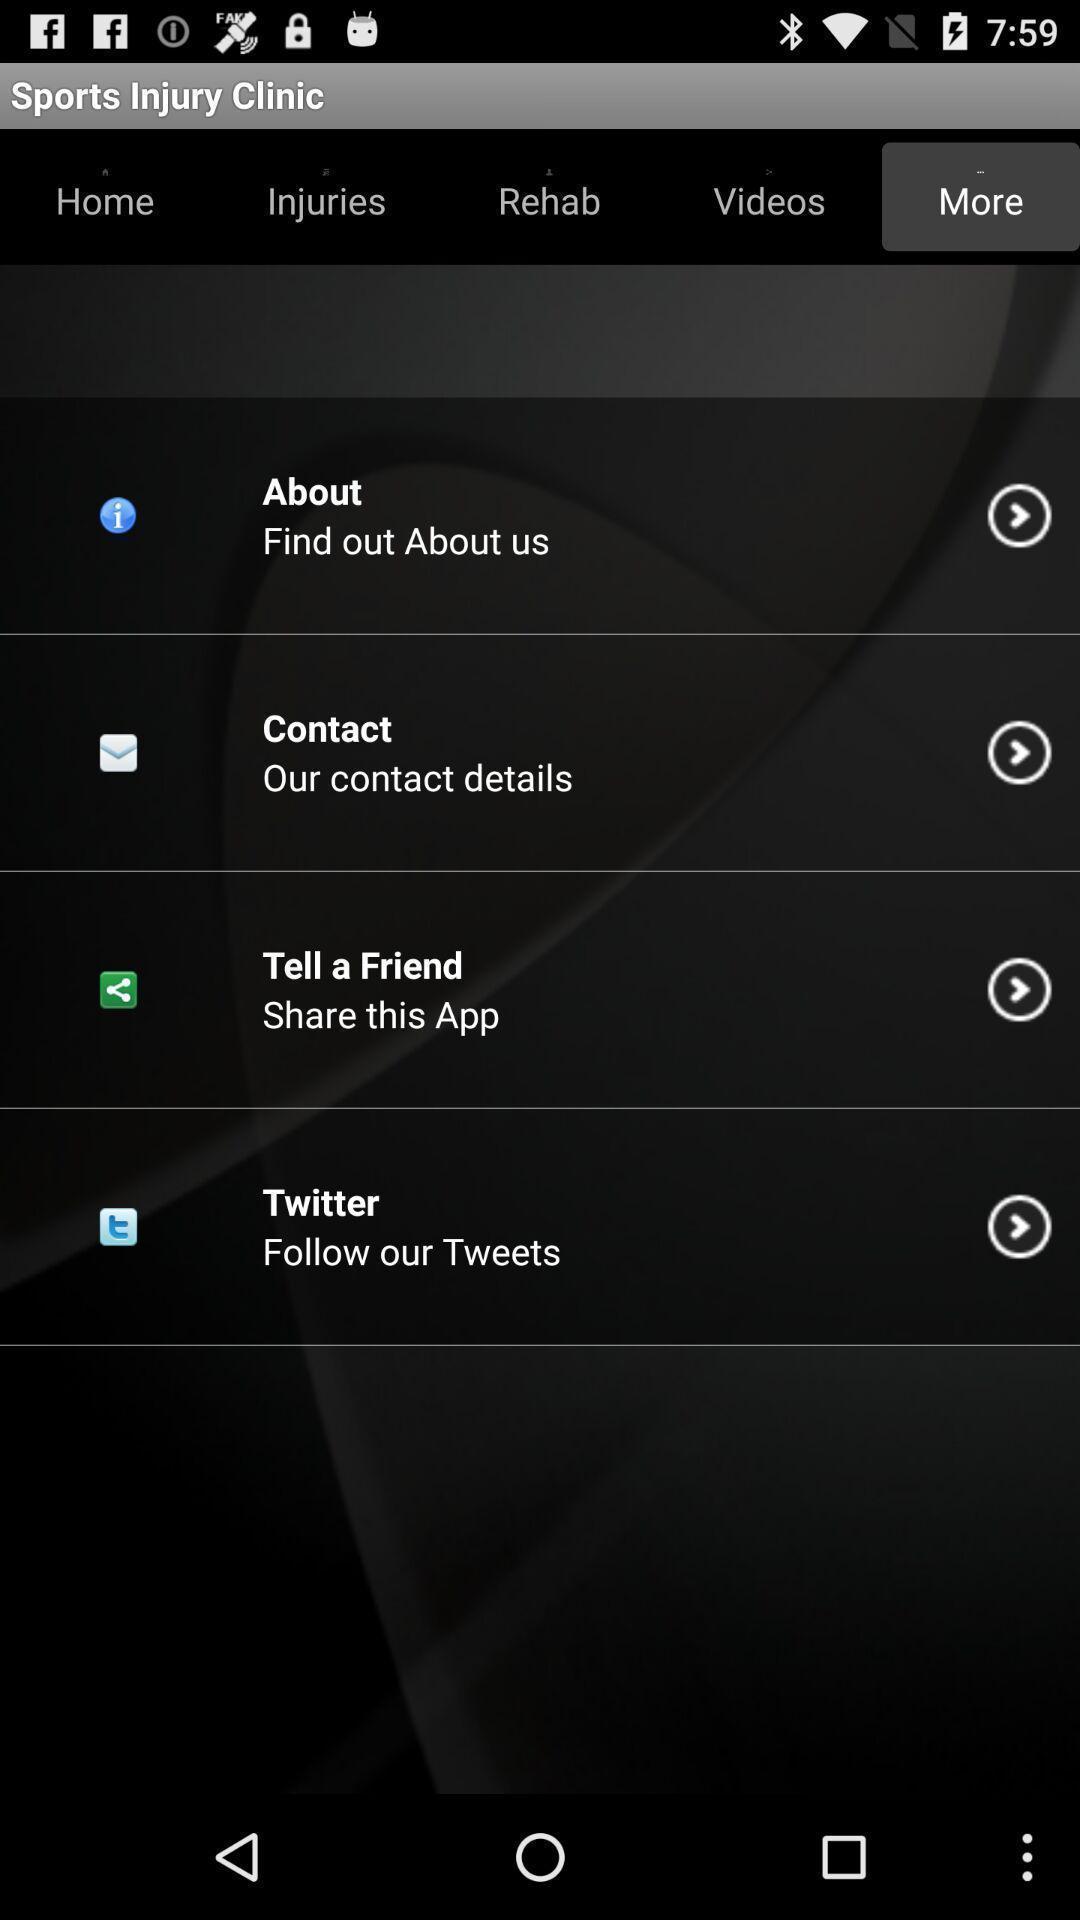Give me a summary of this screen capture. Page that displaying sports application. 